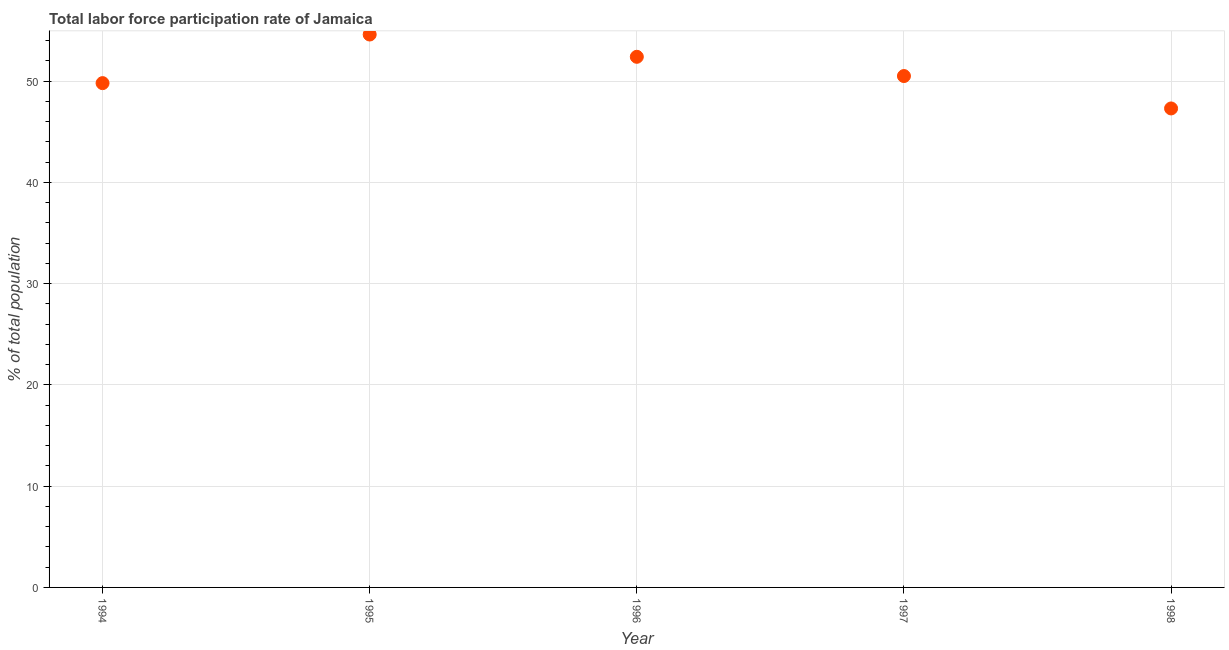What is the total labor force participation rate in 1998?
Your response must be concise. 47.3. Across all years, what is the maximum total labor force participation rate?
Provide a short and direct response. 54.6. Across all years, what is the minimum total labor force participation rate?
Offer a very short reply. 47.3. What is the sum of the total labor force participation rate?
Give a very brief answer. 254.6. What is the difference between the total labor force participation rate in 1997 and 1998?
Offer a very short reply. 3.2. What is the average total labor force participation rate per year?
Offer a very short reply. 50.92. What is the median total labor force participation rate?
Ensure brevity in your answer.  50.5. In how many years, is the total labor force participation rate greater than 36 %?
Provide a succinct answer. 5. What is the ratio of the total labor force participation rate in 1994 to that in 1996?
Your answer should be very brief. 0.95. Is the difference between the total labor force participation rate in 1996 and 1997 greater than the difference between any two years?
Make the answer very short. No. What is the difference between the highest and the second highest total labor force participation rate?
Make the answer very short. 2.2. What is the difference between the highest and the lowest total labor force participation rate?
Provide a succinct answer. 7.3. How many dotlines are there?
Offer a terse response. 1. How many years are there in the graph?
Make the answer very short. 5. Does the graph contain grids?
Your answer should be very brief. Yes. What is the title of the graph?
Offer a very short reply. Total labor force participation rate of Jamaica. What is the label or title of the X-axis?
Your response must be concise. Year. What is the label or title of the Y-axis?
Give a very brief answer. % of total population. What is the % of total population in 1994?
Provide a short and direct response. 49.8. What is the % of total population in 1995?
Make the answer very short. 54.6. What is the % of total population in 1996?
Ensure brevity in your answer.  52.4. What is the % of total population in 1997?
Ensure brevity in your answer.  50.5. What is the % of total population in 1998?
Provide a succinct answer. 47.3. What is the difference between the % of total population in 1994 and 1995?
Your answer should be compact. -4.8. What is the difference between the % of total population in 1994 and 1996?
Your answer should be very brief. -2.6. What is the difference between the % of total population in 1995 and 1997?
Your answer should be compact. 4.1. What is the difference between the % of total population in 1995 and 1998?
Your answer should be very brief. 7.3. What is the difference between the % of total population in 1997 and 1998?
Provide a succinct answer. 3.2. What is the ratio of the % of total population in 1994 to that in 1995?
Your answer should be compact. 0.91. What is the ratio of the % of total population in 1994 to that in 1996?
Ensure brevity in your answer.  0.95. What is the ratio of the % of total population in 1994 to that in 1998?
Your response must be concise. 1.05. What is the ratio of the % of total population in 1995 to that in 1996?
Provide a succinct answer. 1.04. What is the ratio of the % of total population in 1995 to that in 1997?
Provide a short and direct response. 1.08. What is the ratio of the % of total population in 1995 to that in 1998?
Offer a very short reply. 1.15. What is the ratio of the % of total population in 1996 to that in 1997?
Offer a very short reply. 1.04. What is the ratio of the % of total population in 1996 to that in 1998?
Make the answer very short. 1.11. What is the ratio of the % of total population in 1997 to that in 1998?
Offer a very short reply. 1.07. 